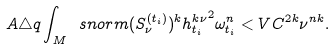Convert formula to latex. <formula><loc_0><loc_0><loc_500><loc_500>A \triangle q \int _ { M } \ s n o r m { ( S _ { \nu } ^ { ( t _ { i } ) } ) ^ { k } } { h _ { t _ { i } } ^ { k \nu } } ^ { 2 } \omega _ { t _ { i } } ^ { n } < V C ^ { 2 k } \nu ^ { n k } .</formula> 